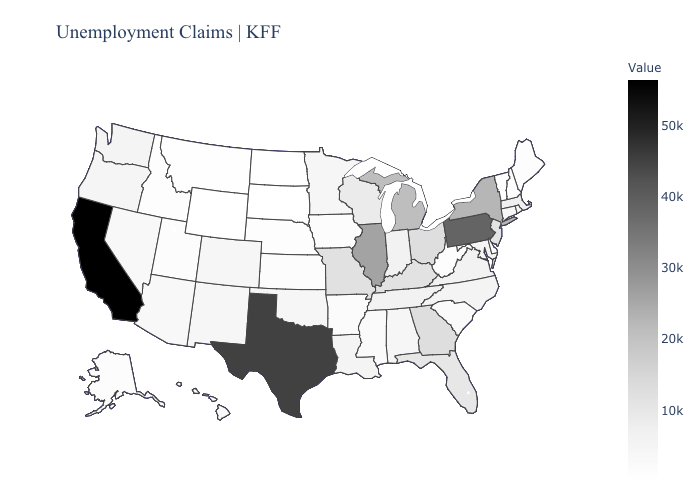Does the map have missing data?
Short answer required. No. Which states have the lowest value in the South?
Keep it brief. Delaware. Is the legend a continuous bar?
Write a very short answer. Yes. Does Vermont have the highest value in the Northeast?
Answer briefly. No. Does the map have missing data?
Keep it brief. No. Does Virginia have the lowest value in the USA?
Quick response, please. No. 